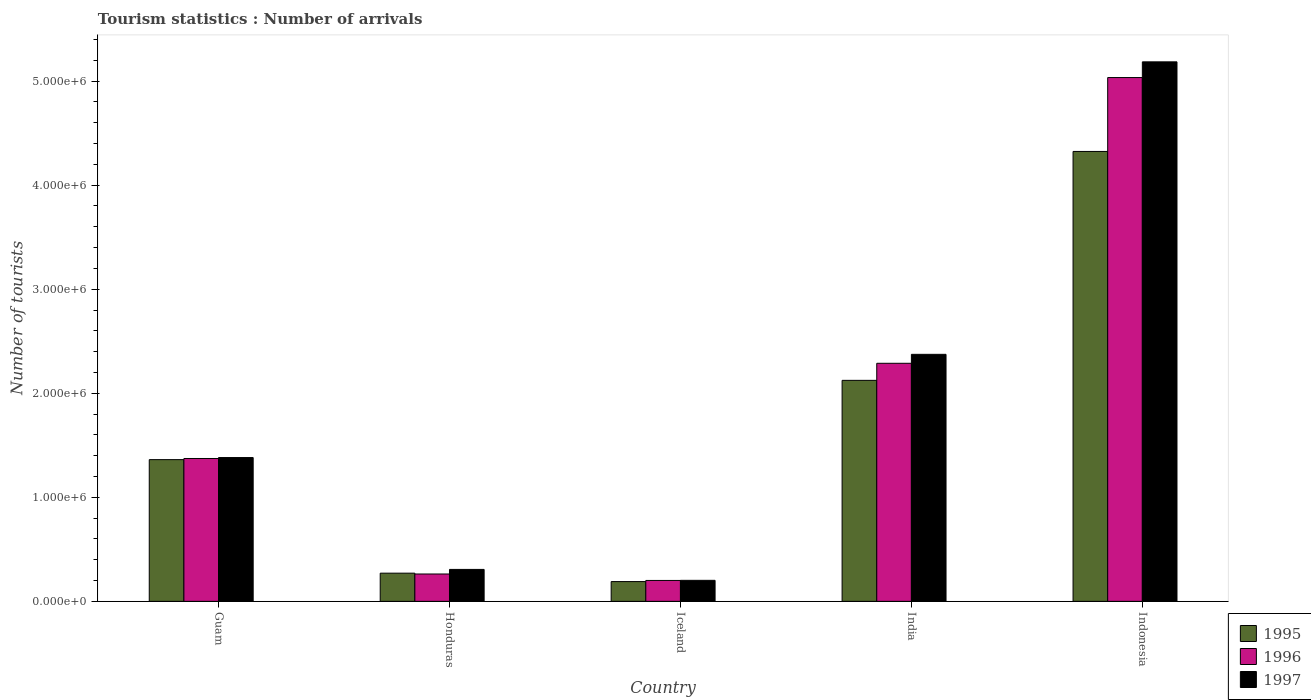Are the number of bars on each tick of the X-axis equal?
Offer a terse response. Yes. What is the label of the 1st group of bars from the left?
Offer a very short reply. Guam. In how many cases, is the number of bars for a given country not equal to the number of legend labels?
Your answer should be very brief. 0. What is the number of tourist arrivals in 1996 in Honduras?
Keep it short and to the point. 2.63e+05. Across all countries, what is the maximum number of tourist arrivals in 1996?
Offer a very short reply. 5.03e+06. Across all countries, what is the minimum number of tourist arrivals in 1995?
Offer a very short reply. 1.90e+05. In which country was the number of tourist arrivals in 1995 maximum?
Your answer should be compact. Indonesia. In which country was the number of tourist arrivals in 1997 minimum?
Ensure brevity in your answer.  Iceland. What is the total number of tourist arrivals in 1997 in the graph?
Keep it short and to the point. 9.45e+06. What is the difference between the number of tourist arrivals in 1997 in Guam and that in Indonesia?
Ensure brevity in your answer.  -3.80e+06. What is the difference between the number of tourist arrivals in 1995 in Iceland and the number of tourist arrivals in 1996 in Indonesia?
Keep it short and to the point. -4.84e+06. What is the average number of tourist arrivals in 1995 per country?
Your answer should be very brief. 1.65e+06. What is the difference between the number of tourist arrivals of/in 1996 and number of tourist arrivals of/in 1995 in Iceland?
Your answer should be compact. 1.10e+04. In how many countries, is the number of tourist arrivals in 1995 greater than 4800000?
Offer a terse response. 0. What is the ratio of the number of tourist arrivals in 1996 in India to that in Indonesia?
Offer a terse response. 0.45. Is the number of tourist arrivals in 1995 in Honduras less than that in India?
Offer a very short reply. Yes. Is the difference between the number of tourist arrivals in 1996 in India and Indonesia greater than the difference between the number of tourist arrivals in 1995 in India and Indonesia?
Provide a succinct answer. No. What is the difference between the highest and the second highest number of tourist arrivals in 1997?
Provide a succinct answer. 3.80e+06. What is the difference between the highest and the lowest number of tourist arrivals in 1997?
Give a very brief answer. 4.98e+06. Is the sum of the number of tourist arrivals in 1997 in Guam and Iceland greater than the maximum number of tourist arrivals in 1995 across all countries?
Offer a terse response. No. What does the 2nd bar from the left in Guam represents?
Make the answer very short. 1996. Is it the case that in every country, the sum of the number of tourist arrivals in 1996 and number of tourist arrivals in 1995 is greater than the number of tourist arrivals in 1997?
Make the answer very short. Yes. How many bars are there?
Make the answer very short. 15. What is the difference between two consecutive major ticks on the Y-axis?
Keep it short and to the point. 1.00e+06. Does the graph contain grids?
Your answer should be very brief. No. How many legend labels are there?
Keep it short and to the point. 3. What is the title of the graph?
Provide a short and direct response. Tourism statistics : Number of arrivals. What is the label or title of the Y-axis?
Keep it short and to the point. Number of tourists. What is the Number of tourists in 1995 in Guam?
Make the answer very short. 1.36e+06. What is the Number of tourists of 1996 in Guam?
Offer a very short reply. 1.37e+06. What is the Number of tourists in 1997 in Guam?
Ensure brevity in your answer.  1.38e+06. What is the Number of tourists in 1995 in Honduras?
Make the answer very short. 2.71e+05. What is the Number of tourists in 1996 in Honduras?
Your answer should be compact. 2.63e+05. What is the Number of tourists in 1997 in Honduras?
Ensure brevity in your answer.  3.07e+05. What is the Number of tourists of 1996 in Iceland?
Your response must be concise. 2.01e+05. What is the Number of tourists in 1997 in Iceland?
Make the answer very short. 2.02e+05. What is the Number of tourists in 1995 in India?
Your answer should be compact. 2.12e+06. What is the Number of tourists in 1996 in India?
Offer a terse response. 2.29e+06. What is the Number of tourists in 1997 in India?
Offer a very short reply. 2.37e+06. What is the Number of tourists of 1995 in Indonesia?
Your answer should be very brief. 4.32e+06. What is the Number of tourists in 1996 in Indonesia?
Your response must be concise. 5.03e+06. What is the Number of tourists in 1997 in Indonesia?
Offer a terse response. 5.18e+06. Across all countries, what is the maximum Number of tourists in 1995?
Provide a short and direct response. 4.32e+06. Across all countries, what is the maximum Number of tourists in 1996?
Your response must be concise. 5.03e+06. Across all countries, what is the maximum Number of tourists in 1997?
Provide a succinct answer. 5.18e+06. Across all countries, what is the minimum Number of tourists in 1996?
Keep it short and to the point. 2.01e+05. Across all countries, what is the minimum Number of tourists of 1997?
Your answer should be compact. 2.02e+05. What is the total Number of tourists in 1995 in the graph?
Offer a very short reply. 8.27e+06. What is the total Number of tourists in 1996 in the graph?
Give a very brief answer. 9.16e+06. What is the total Number of tourists of 1997 in the graph?
Make the answer very short. 9.45e+06. What is the difference between the Number of tourists in 1995 in Guam and that in Honduras?
Ensure brevity in your answer.  1.09e+06. What is the difference between the Number of tourists in 1996 in Guam and that in Honduras?
Ensure brevity in your answer.  1.11e+06. What is the difference between the Number of tourists of 1997 in Guam and that in Honduras?
Make the answer very short. 1.08e+06. What is the difference between the Number of tourists of 1995 in Guam and that in Iceland?
Ensure brevity in your answer.  1.17e+06. What is the difference between the Number of tourists of 1996 in Guam and that in Iceland?
Offer a terse response. 1.17e+06. What is the difference between the Number of tourists in 1997 in Guam and that in Iceland?
Your answer should be compact. 1.18e+06. What is the difference between the Number of tourists in 1995 in Guam and that in India?
Give a very brief answer. -7.62e+05. What is the difference between the Number of tourists of 1996 in Guam and that in India?
Keep it short and to the point. -9.15e+05. What is the difference between the Number of tourists of 1997 in Guam and that in India?
Make the answer very short. -9.92e+05. What is the difference between the Number of tourists in 1995 in Guam and that in Indonesia?
Ensure brevity in your answer.  -2.96e+06. What is the difference between the Number of tourists of 1996 in Guam and that in Indonesia?
Ensure brevity in your answer.  -3.66e+06. What is the difference between the Number of tourists in 1997 in Guam and that in Indonesia?
Give a very brief answer. -3.80e+06. What is the difference between the Number of tourists of 1995 in Honduras and that in Iceland?
Your answer should be very brief. 8.10e+04. What is the difference between the Number of tourists in 1996 in Honduras and that in Iceland?
Offer a terse response. 6.20e+04. What is the difference between the Number of tourists of 1997 in Honduras and that in Iceland?
Give a very brief answer. 1.05e+05. What is the difference between the Number of tourists of 1995 in Honduras and that in India?
Your response must be concise. -1.85e+06. What is the difference between the Number of tourists of 1996 in Honduras and that in India?
Provide a succinct answer. -2.02e+06. What is the difference between the Number of tourists of 1997 in Honduras and that in India?
Keep it short and to the point. -2.07e+06. What is the difference between the Number of tourists in 1995 in Honduras and that in Indonesia?
Your answer should be very brief. -4.05e+06. What is the difference between the Number of tourists of 1996 in Honduras and that in Indonesia?
Provide a short and direct response. -4.77e+06. What is the difference between the Number of tourists of 1997 in Honduras and that in Indonesia?
Your response must be concise. -4.88e+06. What is the difference between the Number of tourists of 1995 in Iceland and that in India?
Ensure brevity in your answer.  -1.93e+06. What is the difference between the Number of tourists in 1996 in Iceland and that in India?
Your answer should be compact. -2.09e+06. What is the difference between the Number of tourists of 1997 in Iceland and that in India?
Give a very brief answer. -2.17e+06. What is the difference between the Number of tourists of 1995 in Iceland and that in Indonesia?
Your answer should be very brief. -4.13e+06. What is the difference between the Number of tourists in 1996 in Iceland and that in Indonesia?
Your answer should be compact. -4.83e+06. What is the difference between the Number of tourists of 1997 in Iceland and that in Indonesia?
Ensure brevity in your answer.  -4.98e+06. What is the difference between the Number of tourists of 1995 in India and that in Indonesia?
Offer a very short reply. -2.20e+06. What is the difference between the Number of tourists in 1996 in India and that in Indonesia?
Ensure brevity in your answer.  -2.75e+06. What is the difference between the Number of tourists of 1997 in India and that in Indonesia?
Your answer should be compact. -2.81e+06. What is the difference between the Number of tourists in 1995 in Guam and the Number of tourists in 1996 in Honduras?
Offer a very short reply. 1.10e+06. What is the difference between the Number of tourists in 1995 in Guam and the Number of tourists in 1997 in Honduras?
Ensure brevity in your answer.  1.06e+06. What is the difference between the Number of tourists in 1996 in Guam and the Number of tourists in 1997 in Honduras?
Keep it short and to the point. 1.07e+06. What is the difference between the Number of tourists in 1995 in Guam and the Number of tourists in 1996 in Iceland?
Your answer should be very brief. 1.16e+06. What is the difference between the Number of tourists of 1995 in Guam and the Number of tourists of 1997 in Iceland?
Keep it short and to the point. 1.16e+06. What is the difference between the Number of tourists of 1996 in Guam and the Number of tourists of 1997 in Iceland?
Provide a short and direct response. 1.17e+06. What is the difference between the Number of tourists of 1995 in Guam and the Number of tourists of 1996 in India?
Ensure brevity in your answer.  -9.26e+05. What is the difference between the Number of tourists of 1995 in Guam and the Number of tourists of 1997 in India?
Give a very brief answer. -1.01e+06. What is the difference between the Number of tourists of 1996 in Guam and the Number of tourists of 1997 in India?
Your answer should be very brief. -1.00e+06. What is the difference between the Number of tourists of 1995 in Guam and the Number of tourists of 1996 in Indonesia?
Offer a very short reply. -3.67e+06. What is the difference between the Number of tourists in 1995 in Guam and the Number of tourists in 1997 in Indonesia?
Your answer should be very brief. -3.82e+06. What is the difference between the Number of tourists in 1996 in Guam and the Number of tourists in 1997 in Indonesia?
Provide a succinct answer. -3.81e+06. What is the difference between the Number of tourists in 1995 in Honduras and the Number of tourists in 1996 in Iceland?
Make the answer very short. 7.00e+04. What is the difference between the Number of tourists of 1995 in Honduras and the Number of tourists of 1997 in Iceland?
Your answer should be very brief. 6.90e+04. What is the difference between the Number of tourists of 1996 in Honduras and the Number of tourists of 1997 in Iceland?
Keep it short and to the point. 6.10e+04. What is the difference between the Number of tourists in 1995 in Honduras and the Number of tourists in 1996 in India?
Ensure brevity in your answer.  -2.02e+06. What is the difference between the Number of tourists in 1995 in Honduras and the Number of tourists in 1997 in India?
Your answer should be very brief. -2.10e+06. What is the difference between the Number of tourists in 1996 in Honduras and the Number of tourists in 1997 in India?
Your answer should be compact. -2.11e+06. What is the difference between the Number of tourists in 1995 in Honduras and the Number of tourists in 1996 in Indonesia?
Give a very brief answer. -4.76e+06. What is the difference between the Number of tourists in 1995 in Honduras and the Number of tourists in 1997 in Indonesia?
Your answer should be very brief. -4.91e+06. What is the difference between the Number of tourists of 1996 in Honduras and the Number of tourists of 1997 in Indonesia?
Keep it short and to the point. -4.92e+06. What is the difference between the Number of tourists of 1995 in Iceland and the Number of tourists of 1996 in India?
Keep it short and to the point. -2.10e+06. What is the difference between the Number of tourists in 1995 in Iceland and the Number of tourists in 1997 in India?
Ensure brevity in your answer.  -2.18e+06. What is the difference between the Number of tourists in 1996 in Iceland and the Number of tourists in 1997 in India?
Ensure brevity in your answer.  -2.17e+06. What is the difference between the Number of tourists in 1995 in Iceland and the Number of tourists in 1996 in Indonesia?
Offer a terse response. -4.84e+06. What is the difference between the Number of tourists of 1995 in Iceland and the Number of tourists of 1997 in Indonesia?
Provide a short and direct response. -5.00e+06. What is the difference between the Number of tourists in 1996 in Iceland and the Number of tourists in 1997 in Indonesia?
Ensure brevity in your answer.  -4.98e+06. What is the difference between the Number of tourists of 1995 in India and the Number of tourists of 1996 in Indonesia?
Provide a succinct answer. -2.91e+06. What is the difference between the Number of tourists in 1995 in India and the Number of tourists in 1997 in Indonesia?
Provide a succinct answer. -3.06e+06. What is the difference between the Number of tourists of 1996 in India and the Number of tourists of 1997 in Indonesia?
Your answer should be very brief. -2.90e+06. What is the average Number of tourists of 1995 per country?
Keep it short and to the point. 1.65e+06. What is the average Number of tourists in 1996 per country?
Your answer should be very brief. 1.83e+06. What is the average Number of tourists in 1997 per country?
Your answer should be very brief. 1.89e+06. What is the difference between the Number of tourists of 1995 and Number of tourists of 1996 in Guam?
Ensure brevity in your answer.  -1.10e+04. What is the difference between the Number of tourists of 1996 and Number of tourists of 1997 in Guam?
Ensure brevity in your answer.  -9000. What is the difference between the Number of tourists of 1995 and Number of tourists of 1996 in Honduras?
Your response must be concise. 8000. What is the difference between the Number of tourists of 1995 and Number of tourists of 1997 in Honduras?
Offer a very short reply. -3.60e+04. What is the difference between the Number of tourists of 1996 and Number of tourists of 1997 in Honduras?
Your response must be concise. -4.40e+04. What is the difference between the Number of tourists of 1995 and Number of tourists of 1996 in Iceland?
Ensure brevity in your answer.  -1.10e+04. What is the difference between the Number of tourists of 1995 and Number of tourists of 1997 in Iceland?
Make the answer very short. -1.20e+04. What is the difference between the Number of tourists of 1996 and Number of tourists of 1997 in Iceland?
Your answer should be very brief. -1000. What is the difference between the Number of tourists in 1995 and Number of tourists in 1996 in India?
Offer a terse response. -1.64e+05. What is the difference between the Number of tourists in 1995 and Number of tourists in 1997 in India?
Offer a terse response. -2.50e+05. What is the difference between the Number of tourists of 1996 and Number of tourists of 1997 in India?
Provide a succinct answer. -8.60e+04. What is the difference between the Number of tourists of 1995 and Number of tourists of 1996 in Indonesia?
Give a very brief answer. -7.10e+05. What is the difference between the Number of tourists of 1995 and Number of tourists of 1997 in Indonesia?
Make the answer very short. -8.61e+05. What is the difference between the Number of tourists of 1996 and Number of tourists of 1997 in Indonesia?
Offer a terse response. -1.51e+05. What is the ratio of the Number of tourists in 1995 in Guam to that in Honduras?
Your response must be concise. 5.03. What is the ratio of the Number of tourists in 1996 in Guam to that in Honduras?
Your answer should be compact. 5.22. What is the ratio of the Number of tourists in 1997 in Guam to that in Honduras?
Offer a terse response. 4.5. What is the ratio of the Number of tourists in 1995 in Guam to that in Iceland?
Offer a very short reply. 7.17. What is the ratio of the Number of tourists of 1996 in Guam to that in Iceland?
Offer a terse response. 6.83. What is the ratio of the Number of tourists of 1997 in Guam to that in Iceland?
Provide a short and direct response. 6.84. What is the ratio of the Number of tourists of 1995 in Guam to that in India?
Provide a succinct answer. 0.64. What is the ratio of the Number of tourists in 1996 in Guam to that in India?
Provide a short and direct response. 0.6. What is the ratio of the Number of tourists of 1997 in Guam to that in India?
Your answer should be very brief. 0.58. What is the ratio of the Number of tourists in 1995 in Guam to that in Indonesia?
Keep it short and to the point. 0.32. What is the ratio of the Number of tourists of 1996 in Guam to that in Indonesia?
Your answer should be very brief. 0.27. What is the ratio of the Number of tourists of 1997 in Guam to that in Indonesia?
Your answer should be compact. 0.27. What is the ratio of the Number of tourists in 1995 in Honduras to that in Iceland?
Keep it short and to the point. 1.43. What is the ratio of the Number of tourists in 1996 in Honduras to that in Iceland?
Keep it short and to the point. 1.31. What is the ratio of the Number of tourists of 1997 in Honduras to that in Iceland?
Provide a short and direct response. 1.52. What is the ratio of the Number of tourists in 1995 in Honduras to that in India?
Make the answer very short. 0.13. What is the ratio of the Number of tourists of 1996 in Honduras to that in India?
Give a very brief answer. 0.11. What is the ratio of the Number of tourists of 1997 in Honduras to that in India?
Your answer should be very brief. 0.13. What is the ratio of the Number of tourists of 1995 in Honduras to that in Indonesia?
Offer a very short reply. 0.06. What is the ratio of the Number of tourists of 1996 in Honduras to that in Indonesia?
Your answer should be very brief. 0.05. What is the ratio of the Number of tourists of 1997 in Honduras to that in Indonesia?
Your answer should be compact. 0.06. What is the ratio of the Number of tourists in 1995 in Iceland to that in India?
Provide a short and direct response. 0.09. What is the ratio of the Number of tourists in 1996 in Iceland to that in India?
Your answer should be compact. 0.09. What is the ratio of the Number of tourists of 1997 in Iceland to that in India?
Your answer should be very brief. 0.09. What is the ratio of the Number of tourists in 1995 in Iceland to that in Indonesia?
Your answer should be very brief. 0.04. What is the ratio of the Number of tourists in 1996 in Iceland to that in Indonesia?
Provide a succinct answer. 0.04. What is the ratio of the Number of tourists of 1997 in Iceland to that in Indonesia?
Offer a terse response. 0.04. What is the ratio of the Number of tourists in 1995 in India to that in Indonesia?
Keep it short and to the point. 0.49. What is the ratio of the Number of tourists in 1996 in India to that in Indonesia?
Offer a very short reply. 0.45. What is the ratio of the Number of tourists in 1997 in India to that in Indonesia?
Your answer should be very brief. 0.46. What is the difference between the highest and the second highest Number of tourists in 1995?
Offer a very short reply. 2.20e+06. What is the difference between the highest and the second highest Number of tourists of 1996?
Offer a very short reply. 2.75e+06. What is the difference between the highest and the second highest Number of tourists of 1997?
Offer a very short reply. 2.81e+06. What is the difference between the highest and the lowest Number of tourists in 1995?
Your answer should be compact. 4.13e+06. What is the difference between the highest and the lowest Number of tourists of 1996?
Give a very brief answer. 4.83e+06. What is the difference between the highest and the lowest Number of tourists of 1997?
Ensure brevity in your answer.  4.98e+06. 